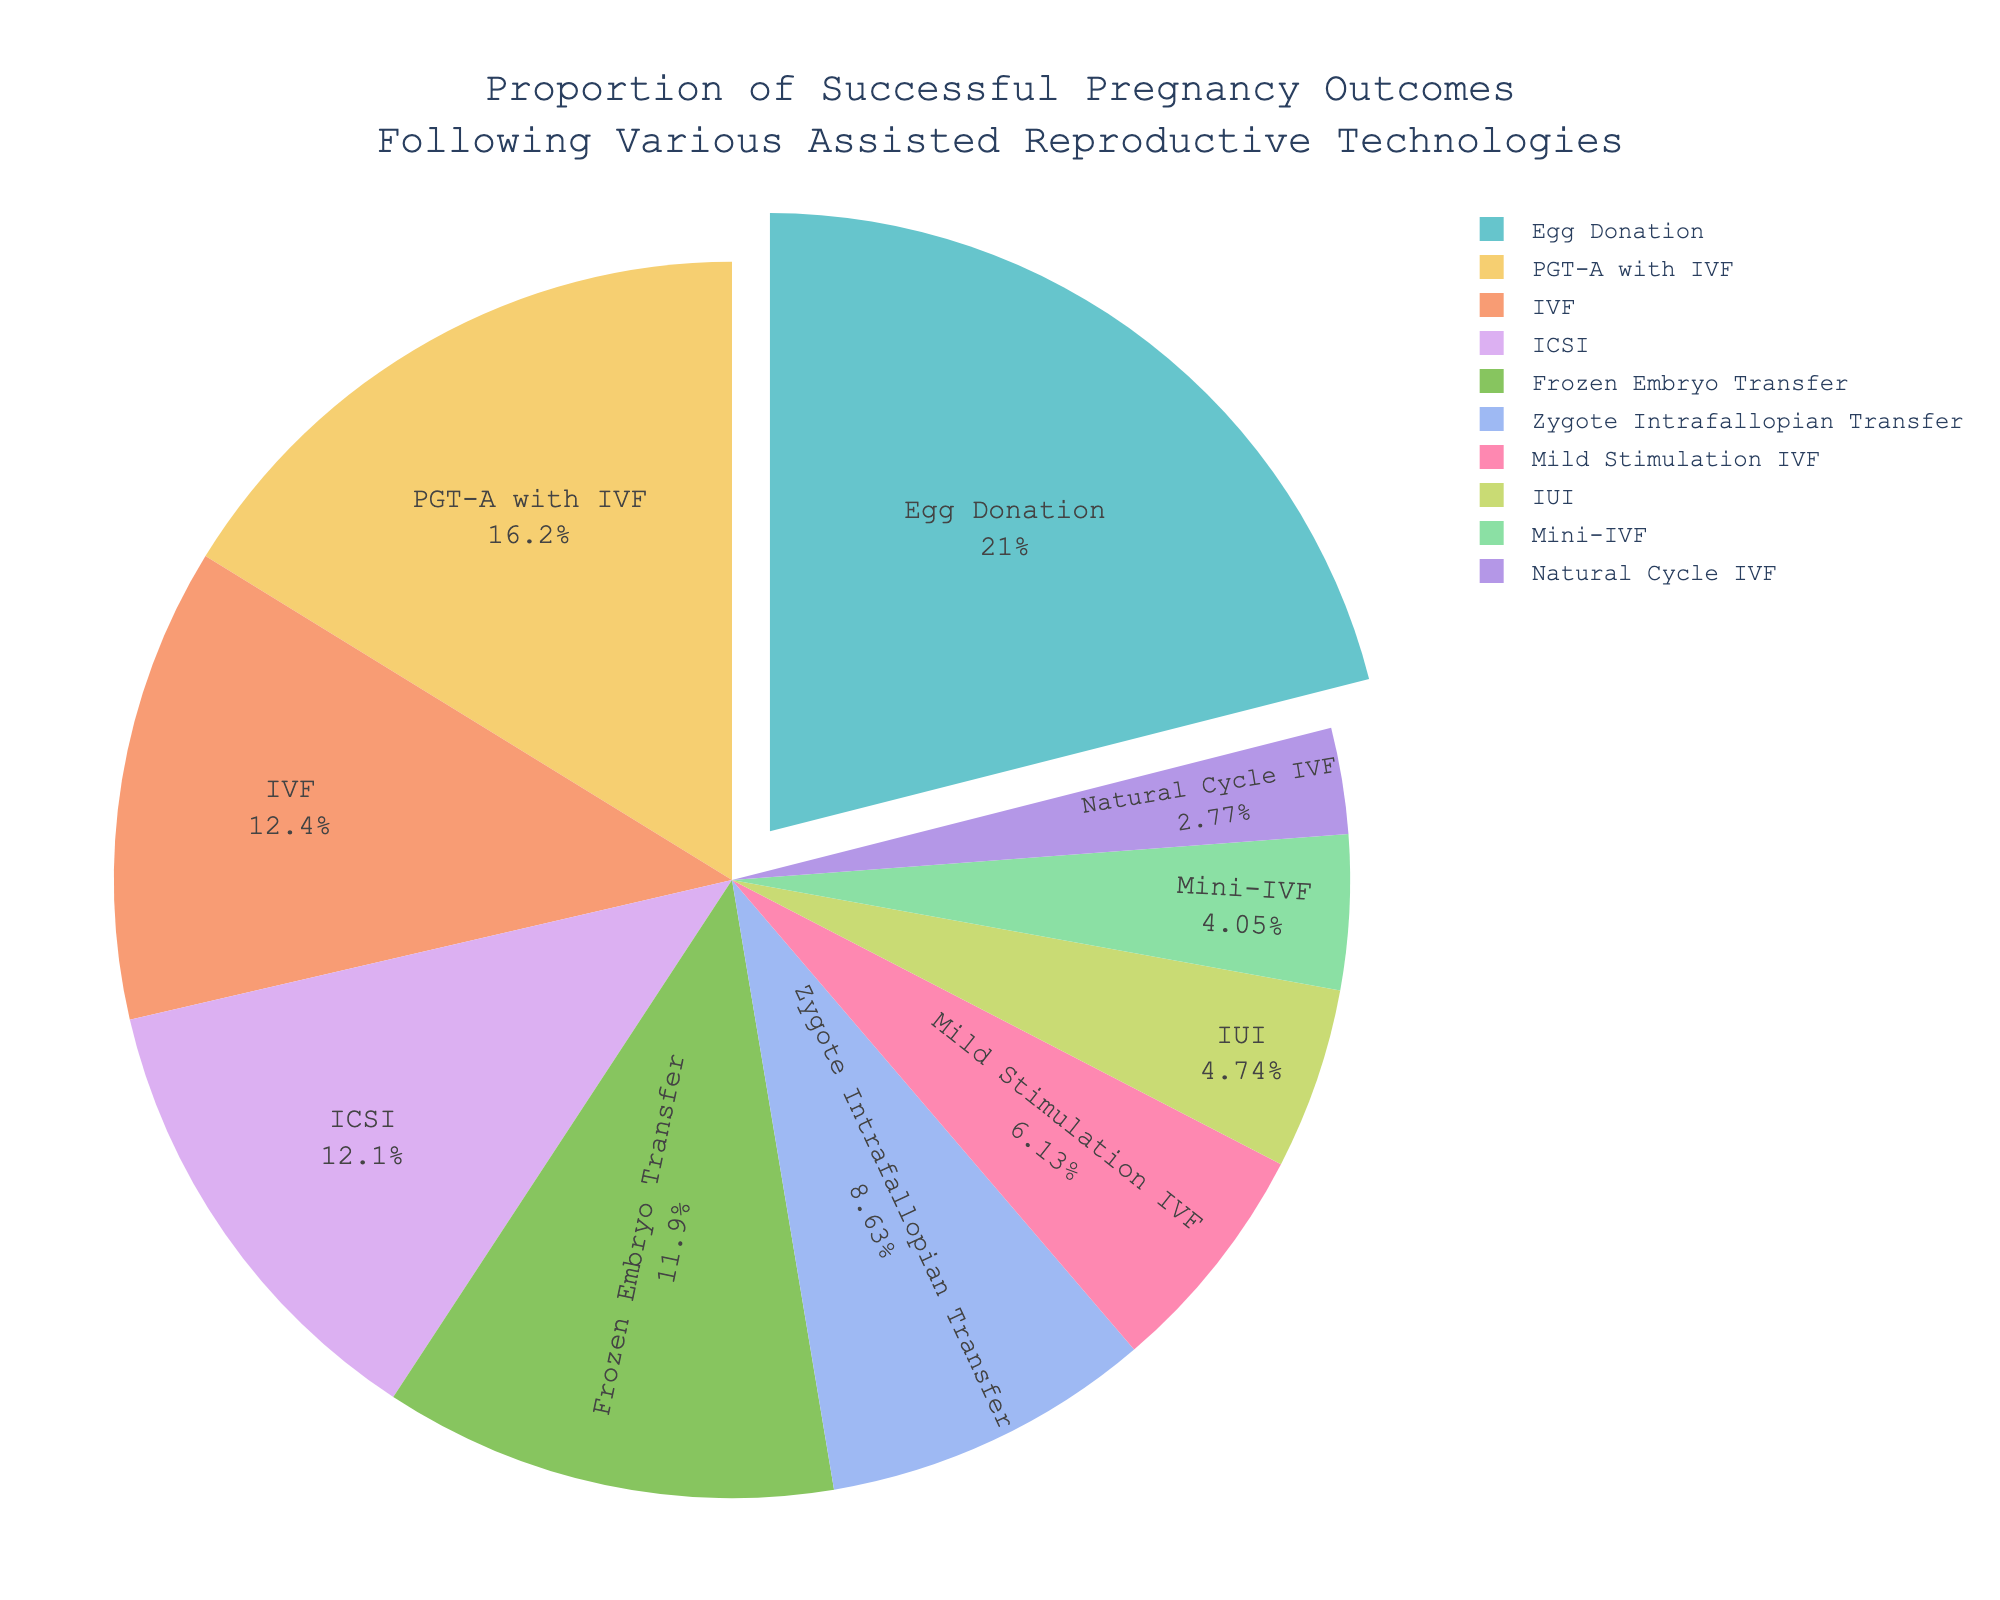What is the success rate of Egg Donation? The success rate of Egg Donation can be found by looking at the slice of the pie chart labeled "Egg Donation" and reading the associated success rate.
Answer: 54.6% Which assisted reproductive technology has the lowest success rate? The lowest success rate can be identified by finding the smallest slice in the pie chart. The label for this slice will show the assisted reproductive technology with the lowest success rate.
Answer: Natural Cycle IVF How does the success rate of IVF compare to ICSI? To compare the success rates of IVF and ICSI, examine the slices of the pie chart labeled "IVF" and "ICSI" and compare their success rates.
Answer: IVF (32.2%) is slightly higher than ICSI (31.5%) What is the combined success rate of IUI, Mini-IVF, and Natural Cycle IVF? Add the success rates of IUI, Mini-IVF, and Natural Cycle IVF by locating their respective slices in the pie chart and summing their success rates (12.3% + 10.5% + 7.2%).
Answer: 30.0% Which assisted reproductive technology has a success rate above 50%? Find the slices in the pie chart with success rates above 50% and identify the corresponding assisted reproductive technology.
Answer: Egg Donation What is the difference in success rate between the highest and lowest success rates? Identify the highest and lowest success rates by examining the pie chart, then calculate the difference (54.6% for Egg Donation and 7.2% for Natural Cycle IVF).
Answer: 47.4% Which technology has a visually distinct slice in the pie chart that appears pulled out? The pulled-out slice is visually distinct and represents the technology with the highest success rate.
Answer: Egg Donation What is the average success rate of all listed assisted reproductive technologies? Add all the success rates, then divide by the number of technologies. (32.2 + 31.5 + 30.8 + 54.6 + 12.3 + 7.2 + 15.9 + 42.1 + 10.5 + 22.4) / 10.
Answer: 25.95% What is the median success rate of the given treatments? Arrange the success rates in ascending order and identify the middle value (7.2, 10.5, 12.3, 15.9, 22.4, 30.8, 31.5, 32.2, 42.1, 54.6). The median is the average of the 5th and 6th values.
Answer: 26.6% Which technology’s success rate is closest to the average success rate of 25.95%? Compare the success rates of each technology to the average success rate (25.95%) and identify which is closest.
Answer: Zygote Intrafallopian Transfer (22.4%) 